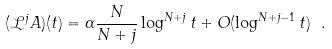Convert formula to latex. <formula><loc_0><loc_0><loc_500><loc_500>( \mathcal { L } ^ { j } A ) ( t ) = \alpha \frac { N } { N + j } \log ^ { N + j } t + O ( \log ^ { N + j - 1 } t ) \ .</formula> 